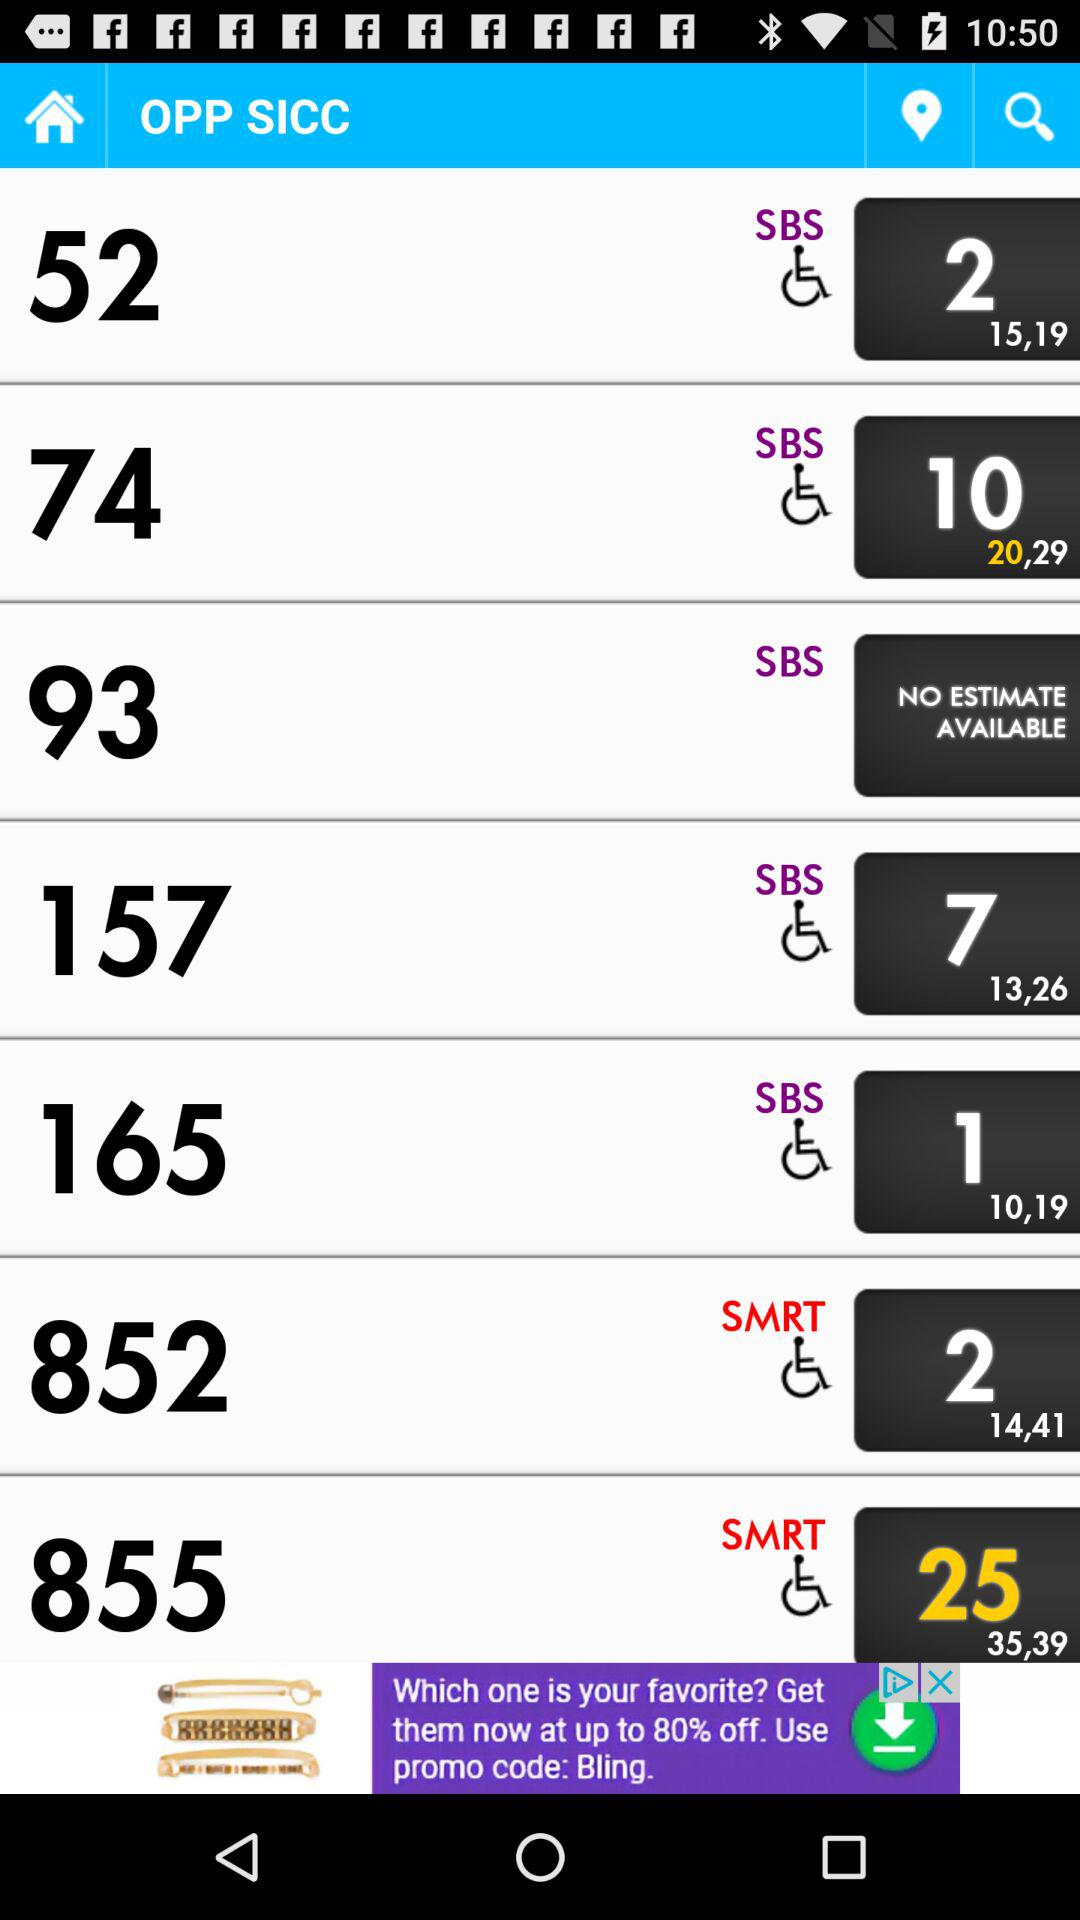What is the application Name?
When the provided information is insufficient, respond with <no answer>. <no answer> 